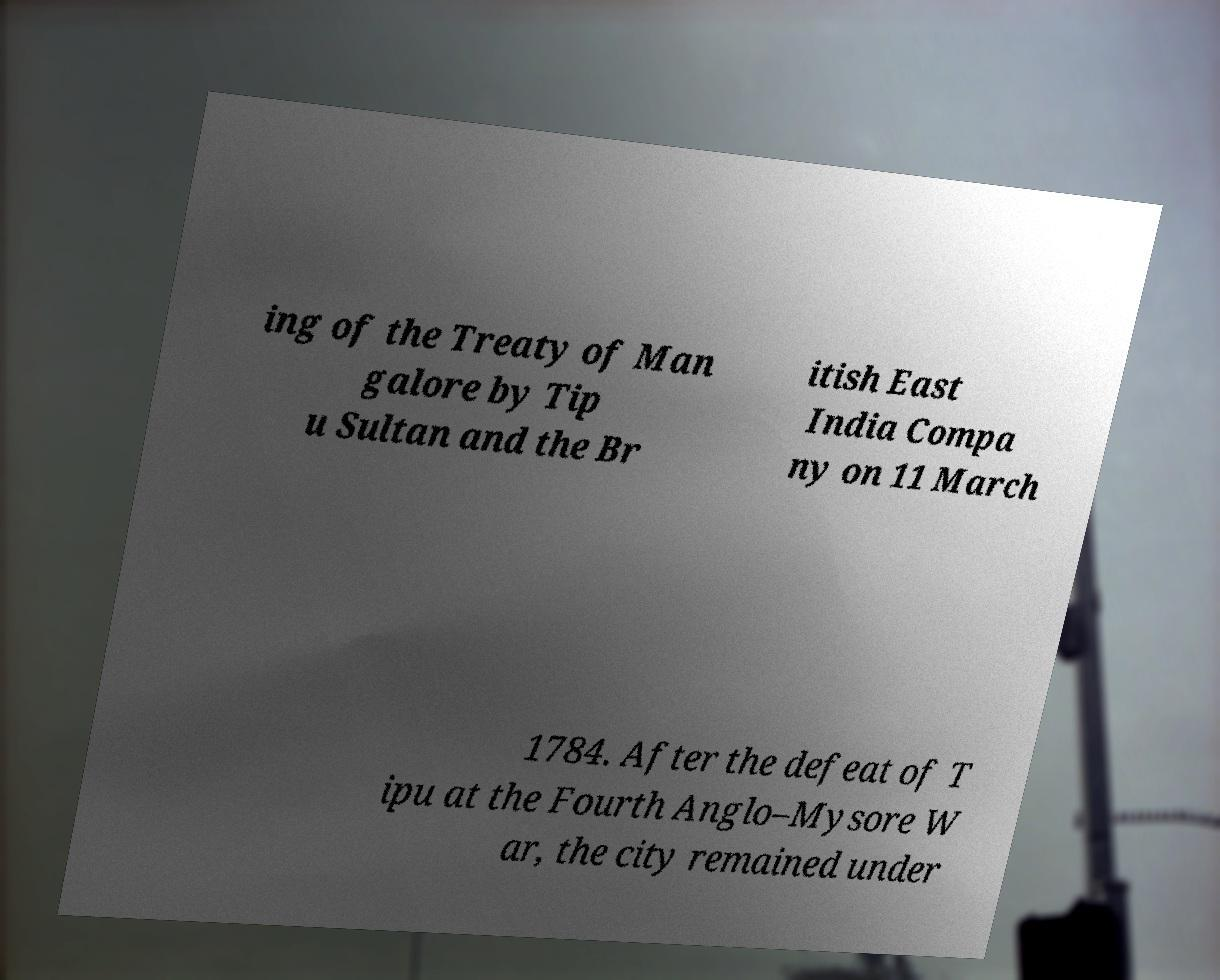Please read and relay the text visible in this image. What does it say? ing of the Treaty of Man galore by Tip u Sultan and the Br itish East India Compa ny on 11 March 1784. After the defeat of T ipu at the Fourth Anglo–Mysore W ar, the city remained under 